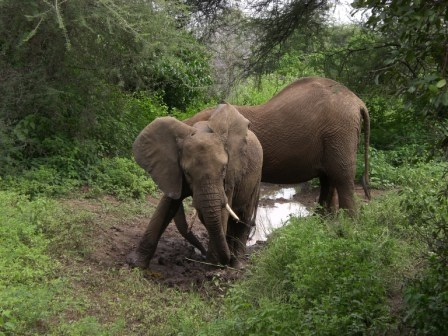Describe the objects in this image and their specific colors. I can see elephant in gray and black tones and elephant in gray and black tones in this image. 